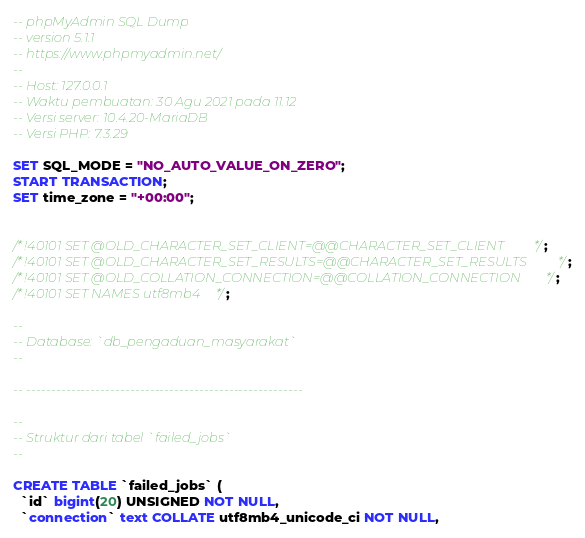Convert code to text. <code><loc_0><loc_0><loc_500><loc_500><_SQL_>-- phpMyAdmin SQL Dump
-- version 5.1.1
-- https://www.phpmyadmin.net/
--
-- Host: 127.0.0.1
-- Waktu pembuatan: 30 Agu 2021 pada 11.12
-- Versi server: 10.4.20-MariaDB
-- Versi PHP: 7.3.29

SET SQL_MODE = "NO_AUTO_VALUE_ON_ZERO";
START TRANSACTION;
SET time_zone = "+00:00";


/*!40101 SET @OLD_CHARACTER_SET_CLIENT=@@CHARACTER_SET_CLIENT */;
/*!40101 SET @OLD_CHARACTER_SET_RESULTS=@@CHARACTER_SET_RESULTS */;
/*!40101 SET @OLD_COLLATION_CONNECTION=@@COLLATION_CONNECTION */;
/*!40101 SET NAMES utf8mb4 */;

--
-- Database: `db_pengaduan_masyarakat`
--

-- --------------------------------------------------------

--
-- Struktur dari tabel `failed_jobs`
--

CREATE TABLE `failed_jobs` (
  `id` bigint(20) UNSIGNED NOT NULL,
  `connection` text COLLATE utf8mb4_unicode_ci NOT NULL,</code> 